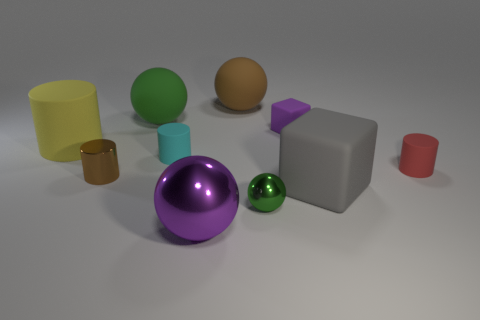Subtract 1 cylinders. How many cylinders are left? 3 Subtract all spheres. How many objects are left? 6 Add 9 green rubber objects. How many green rubber objects exist? 10 Subtract 1 red cylinders. How many objects are left? 9 Subtract all yellow rubber things. Subtract all brown cylinders. How many objects are left? 8 Add 2 big green rubber things. How many big green rubber things are left? 3 